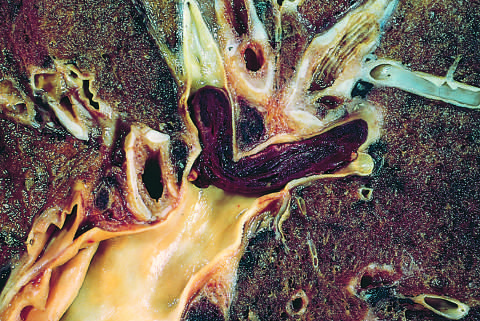what is lodged in a pulmonary artery branch?
Answer the question using a single word or phrase. Embolus 